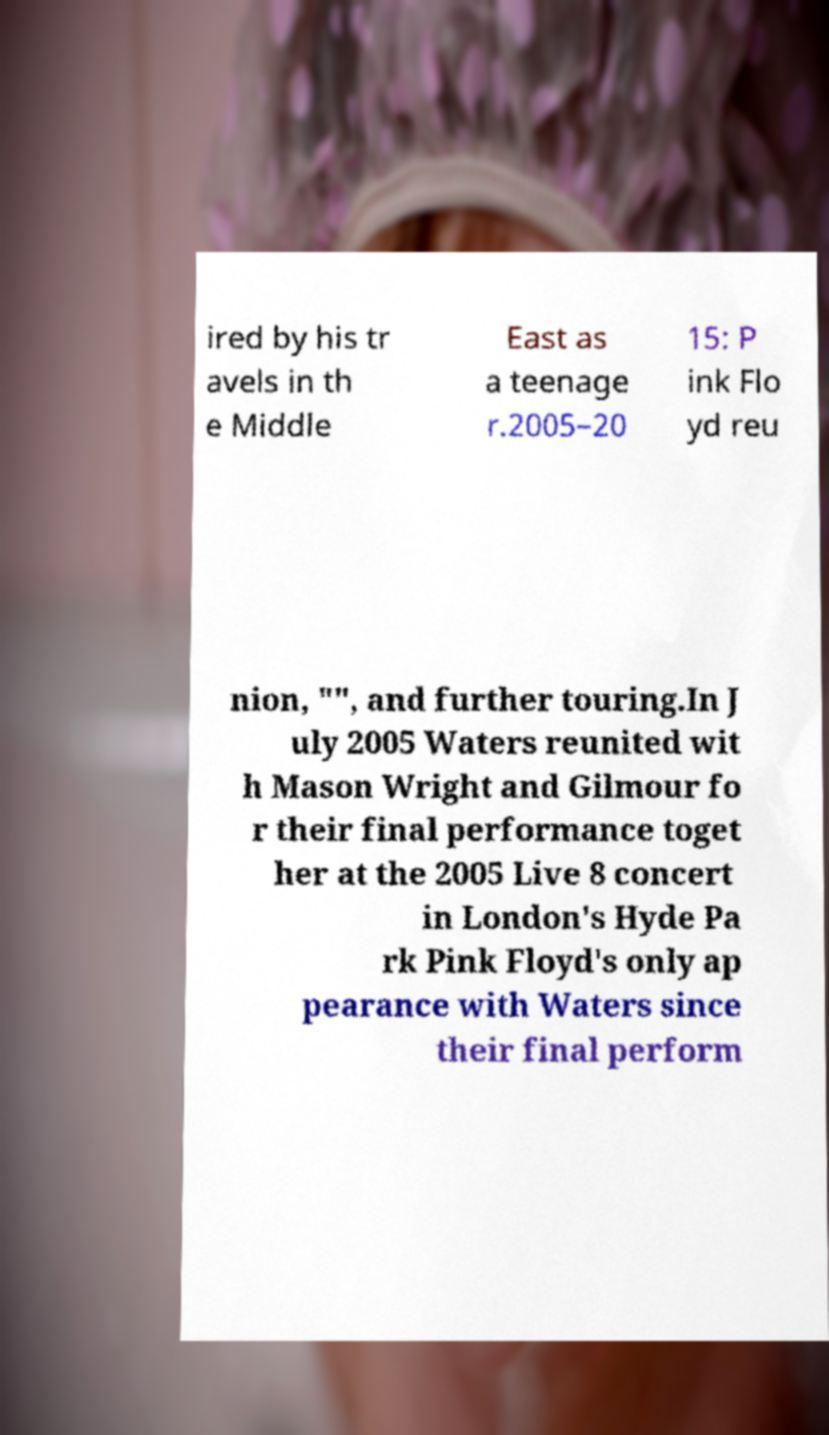Can you read and provide the text displayed in the image?This photo seems to have some interesting text. Can you extract and type it out for me? ired by his tr avels in th e Middle East as a teenage r.2005–20 15: P ink Flo yd reu nion, "", and further touring.In J uly 2005 Waters reunited wit h Mason Wright and Gilmour fo r their final performance toget her at the 2005 Live 8 concert in London's Hyde Pa rk Pink Floyd's only ap pearance with Waters since their final perform 